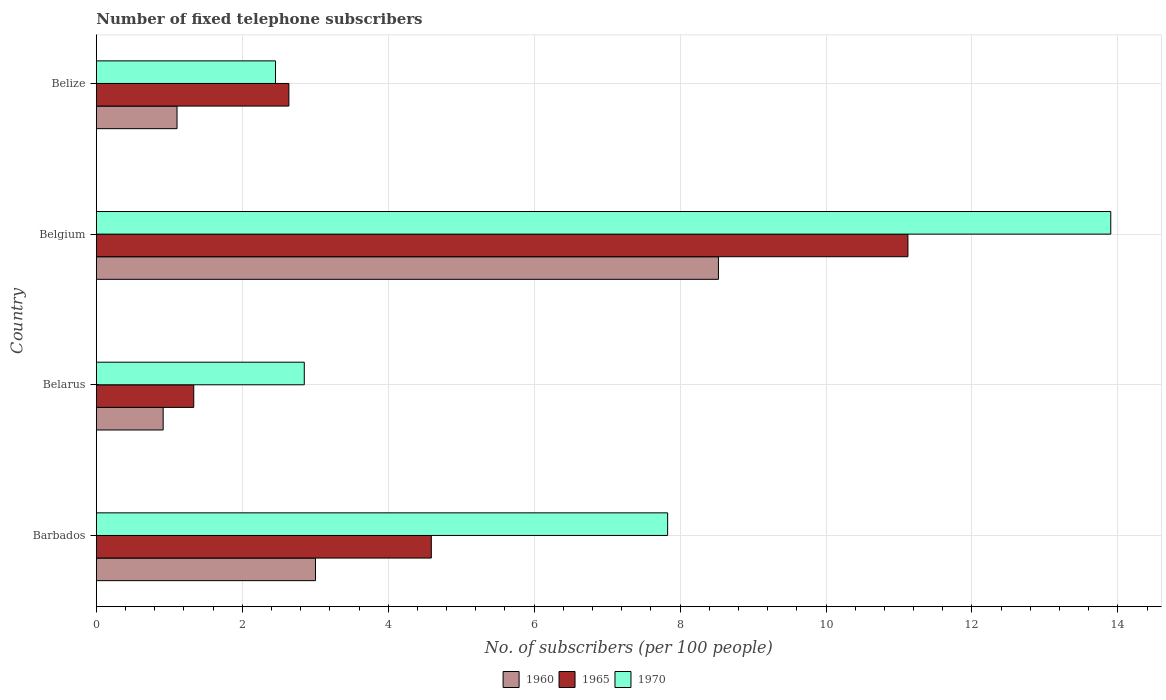How many groups of bars are there?
Offer a terse response. 4. Are the number of bars per tick equal to the number of legend labels?
Make the answer very short. Yes. Are the number of bars on each tick of the Y-axis equal?
Provide a short and direct response. Yes. In how many cases, is the number of bars for a given country not equal to the number of legend labels?
Offer a terse response. 0. What is the number of fixed telephone subscribers in 1960 in Belgium?
Provide a succinct answer. 8.53. Across all countries, what is the maximum number of fixed telephone subscribers in 1970?
Provide a succinct answer. 13.9. Across all countries, what is the minimum number of fixed telephone subscribers in 1970?
Make the answer very short. 2.46. In which country was the number of fixed telephone subscribers in 1965 minimum?
Make the answer very short. Belarus. What is the total number of fixed telephone subscribers in 1970 in the graph?
Offer a very short reply. 27.04. What is the difference between the number of fixed telephone subscribers in 1970 in Belarus and that in Belgium?
Ensure brevity in your answer.  -11.05. What is the difference between the number of fixed telephone subscribers in 1965 in Belize and the number of fixed telephone subscribers in 1960 in Belgium?
Ensure brevity in your answer.  -5.89. What is the average number of fixed telephone subscribers in 1960 per country?
Provide a short and direct response. 3.39. What is the difference between the number of fixed telephone subscribers in 1960 and number of fixed telephone subscribers in 1965 in Belize?
Make the answer very short. -1.53. In how many countries, is the number of fixed telephone subscribers in 1965 greater than 3.2 ?
Your response must be concise. 2. What is the ratio of the number of fixed telephone subscribers in 1970 in Barbados to that in Belize?
Give a very brief answer. 3.19. Is the number of fixed telephone subscribers in 1970 in Barbados less than that in Belgium?
Keep it short and to the point. Yes. Is the difference between the number of fixed telephone subscribers in 1960 in Belarus and Belize greater than the difference between the number of fixed telephone subscribers in 1965 in Belarus and Belize?
Your answer should be compact. Yes. What is the difference between the highest and the second highest number of fixed telephone subscribers in 1970?
Your answer should be very brief. 6.07. What is the difference between the highest and the lowest number of fixed telephone subscribers in 1960?
Provide a succinct answer. 7.61. In how many countries, is the number of fixed telephone subscribers in 1970 greater than the average number of fixed telephone subscribers in 1970 taken over all countries?
Provide a short and direct response. 2. What does the 1st bar from the top in Barbados represents?
Keep it short and to the point. 1970. What does the 2nd bar from the bottom in Belarus represents?
Provide a short and direct response. 1965. How many bars are there?
Provide a short and direct response. 12. Are all the bars in the graph horizontal?
Your response must be concise. Yes. How many countries are there in the graph?
Provide a succinct answer. 4. Are the values on the major ticks of X-axis written in scientific E-notation?
Your response must be concise. No. Does the graph contain any zero values?
Offer a terse response. No. Where does the legend appear in the graph?
Your answer should be compact. Bottom center. How many legend labels are there?
Offer a terse response. 3. What is the title of the graph?
Provide a succinct answer. Number of fixed telephone subscribers. What is the label or title of the X-axis?
Ensure brevity in your answer.  No. of subscribers (per 100 people). What is the No. of subscribers (per 100 people) of 1960 in Barbados?
Your answer should be very brief. 3. What is the No. of subscribers (per 100 people) of 1965 in Barbados?
Provide a succinct answer. 4.59. What is the No. of subscribers (per 100 people) in 1970 in Barbados?
Make the answer very short. 7.83. What is the No. of subscribers (per 100 people) of 1960 in Belarus?
Provide a short and direct response. 0.92. What is the No. of subscribers (per 100 people) of 1965 in Belarus?
Ensure brevity in your answer.  1.33. What is the No. of subscribers (per 100 people) in 1970 in Belarus?
Your answer should be compact. 2.85. What is the No. of subscribers (per 100 people) in 1960 in Belgium?
Your answer should be very brief. 8.53. What is the No. of subscribers (per 100 people) in 1965 in Belgium?
Your answer should be very brief. 11.12. What is the No. of subscribers (per 100 people) of 1970 in Belgium?
Make the answer very short. 13.9. What is the No. of subscribers (per 100 people) of 1960 in Belize?
Give a very brief answer. 1.11. What is the No. of subscribers (per 100 people) of 1965 in Belize?
Your answer should be very brief. 2.64. What is the No. of subscribers (per 100 people) of 1970 in Belize?
Ensure brevity in your answer.  2.46. Across all countries, what is the maximum No. of subscribers (per 100 people) in 1960?
Provide a short and direct response. 8.53. Across all countries, what is the maximum No. of subscribers (per 100 people) in 1965?
Ensure brevity in your answer.  11.12. Across all countries, what is the maximum No. of subscribers (per 100 people) in 1970?
Give a very brief answer. 13.9. Across all countries, what is the minimum No. of subscribers (per 100 people) of 1960?
Offer a very short reply. 0.92. Across all countries, what is the minimum No. of subscribers (per 100 people) in 1965?
Ensure brevity in your answer.  1.33. Across all countries, what is the minimum No. of subscribers (per 100 people) in 1970?
Make the answer very short. 2.46. What is the total No. of subscribers (per 100 people) of 1960 in the graph?
Offer a very short reply. 13.55. What is the total No. of subscribers (per 100 people) of 1965 in the graph?
Give a very brief answer. 19.69. What is the total No. of subscribers (per 100 people) of 1970 in the graph?
Provide a short and direct response. 27.04. What is the difference between the No. of subscribers (per 100 people) of 1960 in Barbados and that in Belarus?
Give a very brief answer. 2.09. What is the difference between the No. of subscribers (per 100 people) of 1965 in Barbados and that in Belarus?
Provide a succinct answer. 3.26. What is the difference between the No. of subscribers (per 100 people) of 1970 in Barbados and that in Belarus?
Offer a very short reply. 4.98. What is the difference between the No. of subscribers (per 100 people) of 1960 in Barbados and that in Belgium?
Give a very brief answer. -5.52. What is the difference between the No. of subscribers (per 100 people) in 1965 in Barbados and that in Belgium?
Provide a succinct answer. -6.53. What is the difference between the No. of subscribers (per 100 people) in 1970 in Barbados and that in Belgium?
Ensure brevity in your answer.  -6.07. What is the difference between the No. of subscribers (per 100 people) of 1960 in Barbados and that in Belize?
Keep it short and to the point. 1.9. What is the difference between the No. of subscribers (per 100 people) of 1965 in Barbados and that in Belize?
Keep it short and to the point. 1.95. What is the difference between the No. of subscribers (per 100 people) in 1970 in Barbados and that in Belize?
Make the answer very short. 5.37. What is the difference between the No. of subscribers (per 100 people) in 1960 in Belarus and that in Belgium?
Offer a terse response. -7.61. What is the difference between the No. of subscribers (per 100 people) of 1965 in Belarus and that in Belgium?
Provide a succinct answer. -9.79. What is the difference between the No. of subscribers (per 100 people) of 1970 in Belarus and that in Belgium?
Your answer should be compact. -11.05. What is the difference between the No. of subscribers (per 100 people) in 1960 in Belarus and that in Belize?
Offer a terse response. -0.19. What is the difference between the No. of subscribers (per 100 people) in 1965 in Belarus and that in Belize?
Give a very brief answer. -1.3. What is the difference between the No. of subscribers (per 100 people) in 1970 in Belarus and that in Belize?
Give a very brief answer. 0.39. What is the difference between the No. of subscribers (per 100 people) in 1960 in Belgium and that in Belize?
Your answer should be very brief. 7.42. What is the difference between the No. of subscribers (per 100 people) of 1965 in Belgium and that in Belize?
Offer a terse response. 8.48. What is the difference between the No. of subscribers (per 100 people) of 1970 in Belgium and that in Belize?
Give a very brief answer. 11.45. What is the difference between the No. of subscribers (per 100 people) of 1960 in Barbados and the No. of subscribers (per 100 people) of 1965 in Belarus?
Offer a terse response. 1.67. What is the difference between the No. of subscribers (per 100 people) in 1960 in Barbados and the No. of subscribers (per 100 people) in 1970 in Belarus?
Ensure brevity in your answer.  0.15. What is the difference between the No. of subscribers (per 100 people) in 1965 in Barbados and the No. of subscribers (per 100 people) in 1970 in Belarus?
Your response must be concise. 1.74. What is the difference between the No. of subscribers (per 100 people) of 1960 in Barbados and the No. of subscribers (per 100 people) of 1965 in Belgium?
Keep it short and to the point. -8.12. What is the difference between the No. of subscribers (per 100 people) in 1960 in Barbados and the No. of subscribers (per 100 people) in 1970 in Belgium?
Make the answer very short. -10.9. What is the difference between the No. of subscribers (per 100 people) in 1965 in Barbados and the No. of subscribers (per 100 people) in 1970 in Belgium?
Offer a very short reply. -9.31. What is the difference between the No. of subscribers (per 100 people) of 1960 in Barbados and the No. of subscribers (per 100 people) of 1965 in Belize?
Make the answer very short. 0.36. What is the difference between the No. of subscribers (per 100 people) of 1960 in Barbados and the No. of subscribers (per 100 people) of 1970 in Belize?
Provide a short and direct response. 0.55. What is the difference between the No. of subscribers (per 100 people) in 1965 in Barbados and the No. of subscribers (per 100 people) in 1970 in Belize?
Give a very brief answer. 2.13. What is the difference between the No. of subscribers (per 100 people) of 1960 in Belarus and the No. of subscribers (per 100 people) of 1965 in Belgium?
Provide a short and direct response. -10.21. What is the difference between the No. of subscribers (per 100 people) in 1960 in Belarus and the No. of subscribers (per 100 people) in 1970 in Belgium?
Your answer should be very brief. -12.99. What is the difference between the No. of subscribers (per 100 people) of 1965 in Belarus and the No. of subscribers (per 100 people) of 1970 in Belgium?
Make the answer very short. -12.57. What is the difference between the No. of subscribers (per 100 people) of 1960 in Belarus and the No. of subscribers (per 100 people) of 1965 in Belize?
Offer a terse response. -1.72. What is the difference between the No. of subscribers (per 100 people) in 1960 in Belarus and the No. of subscribers (per 100 people) in 1970 in Belize?
Your response must be concise. -1.54. What is the difference between the No. of subscribers (per 100 people) in 1965 in Belarus and the No. of subscribers (per 100 people) in 1970 in Belize?
Your answer should be very brief. -1.12. What is the difference between the No. of subscribers (per 100 people) in 1960 in Belgium and the No. of subscribers (per 100 people) in 1965 in Belize?
Provide a short and direct response. 5.89. What is the difference between the No. of subscribers (per 100 people) in 1960 in Belgium and the No. of subscribers (per 100 people) in 1970 in Belize?
Keep it short and to the point. 6.07. What is the difference between the No. of subscribers (per 100 people) of 1965 in Belgium and the No. of subscribers (per 100 people) of 1970 in Belize?
Make the answer very short. 8.67. What is the average No. of subscribers (per 100 people) of 1960 per country?
Make the answer very short. 3.39. What is the average No. of subscribers (per 100 people) of 1965 per country?
Your answer should be compact. 4.92. What is the average No. of subscribers (per 100 people) in 1970 per country?
Keep it short and to the point. 6.76. What is the difference between the No. of subscribers (per 100 people) in 1960 and No. of subscribers (per 100 people) in 1965 in Barbados?
Keep it short and to the point. -1.59. What is the difference between the No. of subscribers (per 100 people) in 1960 and No. of subscribers (per 100 people) in 1970 in Barbados?
Ensure brevity in your answer.  -4.83. What is the difference between the No. of subscribers (per 100 people) in 1965 and No. of subscribers (per 100 people) in 1970 in Barbados?
Your answer should be compact. -3.24. What is the difference between the No. of subscribers (per 100 people) of 1960 and No. of subscribers (per 100 people) of 1965 in Belarus?
Offer a terse response. -0.42. What is the difference between the No. of subscribers (per 100 people) of 1960 and No. of subscribers (per 100 people) of 1970 in Belarus?
Your answer should be compact. -1.93. What is the difference between the No. of subscribers (per 100 people) in 1965 and No. of subscribers (per 100 people) in 1970 in Belarus?
Offer a very short reply. -1.51. What is the difference between the No. of subscribers (per 100 people) of 1960 and No. of subscribers (per 100 people) of 1965 in Belgium?
Keep it short and to the point. -2.6. What is the difference between the No. of subscribers (per 100 people) of 1960 and No. of subscribers (per 100 people) of 1970 in Belgium?
Offer a very short reply. -5.38. What is the difference between the No. of subscribers (per 100 people) of 1965 and No. of subscribers (per 100 people) of 1970 in Belgium?
Your answer should be compact. -2.78. What is the difference between the No. of subscribers (per 100 people) of 1960 and No. of subscribers (per 100 people) of 1965 in Belize?
Make the answer very short. -1.53. What is the difference between the No. of subscribers (per 100 people) in 1960 and No. of subscribers (per 100 people) in 1970 in Belize?
Provide a succinct answer. -1.35. What is the difference between the No. of subscribers (per 100 people) in 1965 and No. of subscribers (per 100 people) in 1970 in Belize?
Provide a short and direct response. 0.18. What is the ratio of the No. of subscribers (per 100 people) of 1960 in Barbados to that in Belarus?
Ensure brevity in your answer.  3.28. What is the ratio of the No. of subscribers (per 100 people) in 1965 in Barbados to that in Belarus?
Provide a short and direct response. 3.44. What is the ratio of the No. of subscribers (per 100 people) in 1970 in Barbados to that in Belarus?
Your response must be concise. 2.75. What is the ratio of the No. of subscribers (per 100 people) in 1960 in Barbados to that in Belgium?
Provide a succinct answer. 0.35. What is the ratio of the No. of subscribers (per 100 people) of 1965 in Barbados to that in Belgium?
Keep it short and to the point. 0.41. What is the ratio of the No. of subscribers (per 100 people) in 1970 in Barbados to that in Belgium?
Give a very brief answer. 0.56. What is the ratio of the No. of subscribers (per 100 people) in 1960 in Barbados to that in Belize?
Ensure brevity in your answer.  2.72. What is the ratio of the No. of subscribers (per 100 people) in 1965 in Barbados to that in Belize?
Ensure brevity in your answer.  1.74. What is the ratio of the No. of subscribers (per 100 people) in 1970 in Barbados to that in Belize?
Your answer should be compact. 3.19. What is the ratio of the No. of subscribers (per 100 people) in 1960 in Belarus to that in Belgium?
Offer a very short reply. 0.11. What is the ratio of the No. of subscribers (per 100 people) in 1965 in Belarus to that in Belgium?
Provide a succinct answer. 0.12. What is the ratio of the No. of subscribers (per 100 people) of 1970 in Belarus to that in Belgium?
Make the answer very short. 0.2. What is the ratio of the No. of subscribers (per 100 people) of 1960 in Belarus to that in Belize?
Offer a very short reply. 0.83. What is the ratio of the No. of subscribers (per 100 people) of 1965 in Belarus to that in Belize?
Your answer should be very brief. 0.51. What is the ratio of the No. of subscribers (per 100 people) of 1970 in Belarus to that in Belize?
Your answer should be very brief. 1.16. What is the ratio of the No. of subscribers (per 100 people) in 1960 in Belgium to that in Belize?
Offer a terse response. 7.71. What is the ratio of the No. of subscribers (per 100 people) in 1965 in Belgium to that in Belize?
Your answer should be compact. 4.22. What is the ratio of the No. of subscribers (per 100 people) in 1970 in Belgium to that in Belize?
Your answer should be very brief. 5.66. What is the difference between the highest and the second highest No. of subscribers (per 100 people) of 1960?
Your response must be concise. 5.52. What is the difference between the highest and the second highest No. of subscribers (per 100 people) of 1965?
Provide a succinct answer. 6.53. What is the difference between the highest and the second highest No. of subscribers (per 100 people) of 1970?
Your answer should be compact. 6.07. What is the difference between the highest and the lowest No. of subscribers (per 100 people) of 1960?
Your answer should be very brief. 7.61. What is the difference between the highest and the lowest No. of subscribers (per 100 people) in 1965?
Make the answer very short. 9.79. What is the difference between the highest and the lowest No. of subscribers (per 100 people) in 1970?
Offer a very short reply. 11.45. 